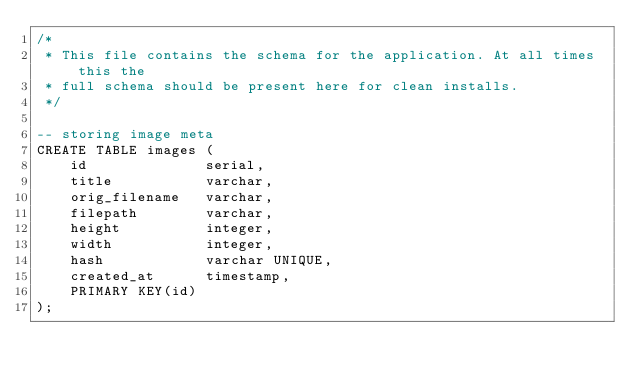Convert code to text. <code><loc_0><loc_0><loc_500><loc_500><_SQL_>/*
 * This file contains the schema for the application. At all times this the
 * full schema should be present here for clean installs.
 */

-- storing image meta
CREATE TABLE images (
    id              serial,
    title           varchar,
    orig_filename   varchar,
    filepath        varchar,
    height          integer,
    width           integer,
    hash            varchar UNIQUE,
    created_at      timestamp,
    PRIMARY KEY(id)
);</code> 